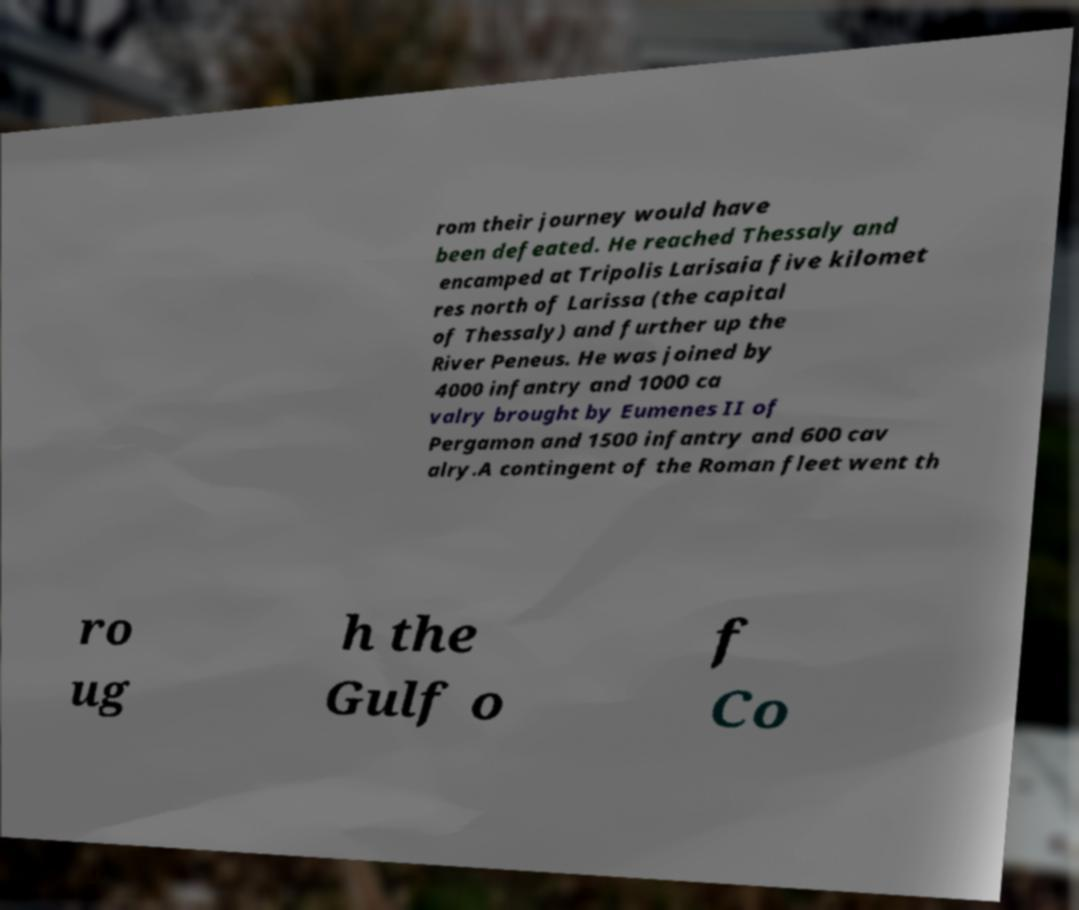Can you accurately transcribe the text from the provided image for me? rom their journey would have been defeated. He reached Thessaly and encamped at Tripolis Larisaia five kilomet res north of Larissa (the capital of Thessaly) and further up the River Peneus. He was joined by 4000 infantry and 1000 ca valry brought by Eumenes II of Pergamon and 1500 infantry and 600 cav alry.A contingent of the Roman fleet went th ro ug h the Gulf o f Co 